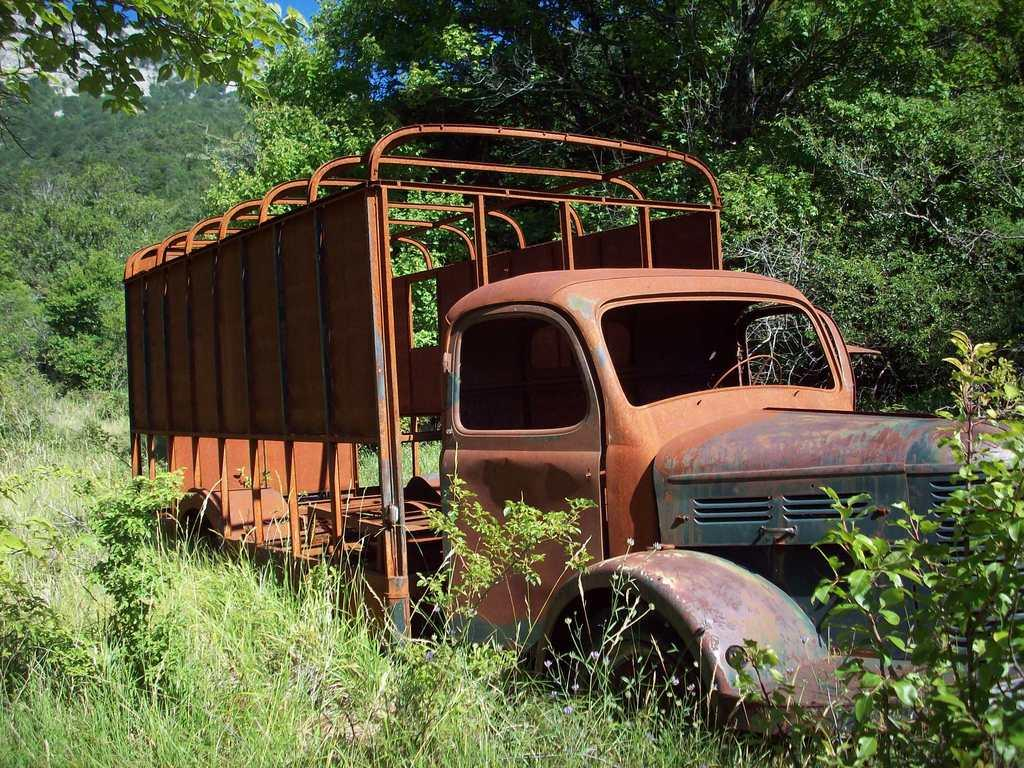What is on the ground in the image? There is a vehicle on the ground in the image. What type of vegetation can be seen in the image? There are plants, trees, and grass in the image. What part of the natural environment is visible in the image? The sky is visible in the image. What type of pets can be seen wearing underwear in the image? There are no pets or underwear present in the image. 